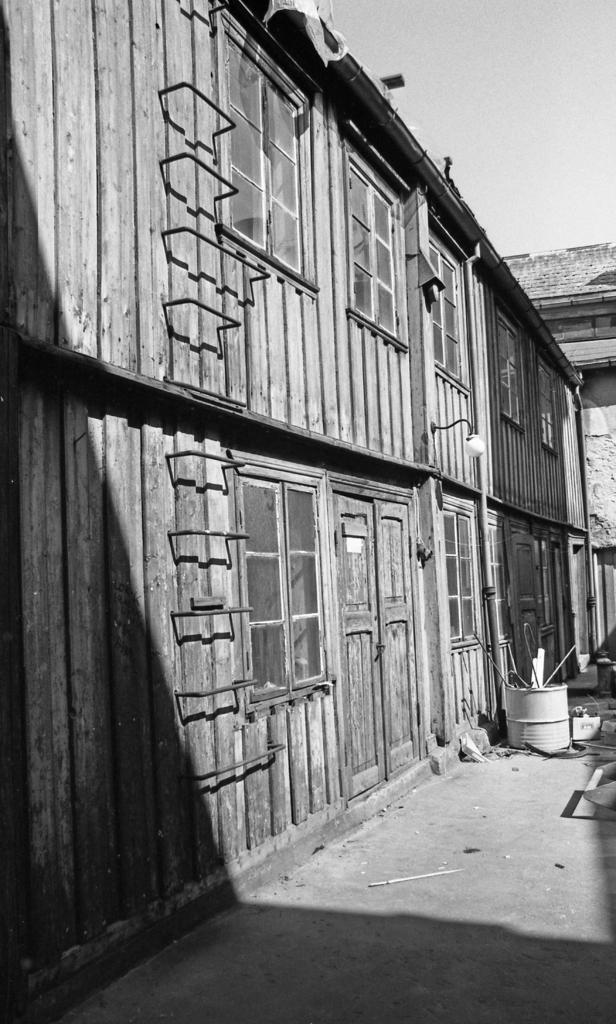What structure is located on the left side of the image? There is a house on the left side of the image. What type of windows are on the house? The house has glass windows. What is the door on the house made of? The door on the house is made of wood. What object is on the ground near the house? There is a white-colored barrel on the ground. What is visible at the top of the image? The sky is visible at the top of the image. Where is the gate located in the image? There is no gate present in the image. What type of crate can be seen near the barrel in the image? There is no crate present in the image; only a white-colored barrel is visible. 